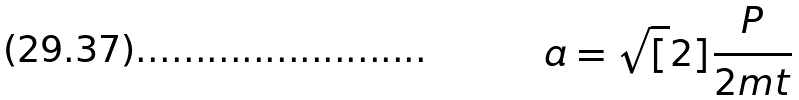Convert formula to latex. <formula><loc_0><loc_0><loc_500><loc_500>a = \sqrt { [ } 2 ] { \frac { P } { 2 m t } }</formula> 